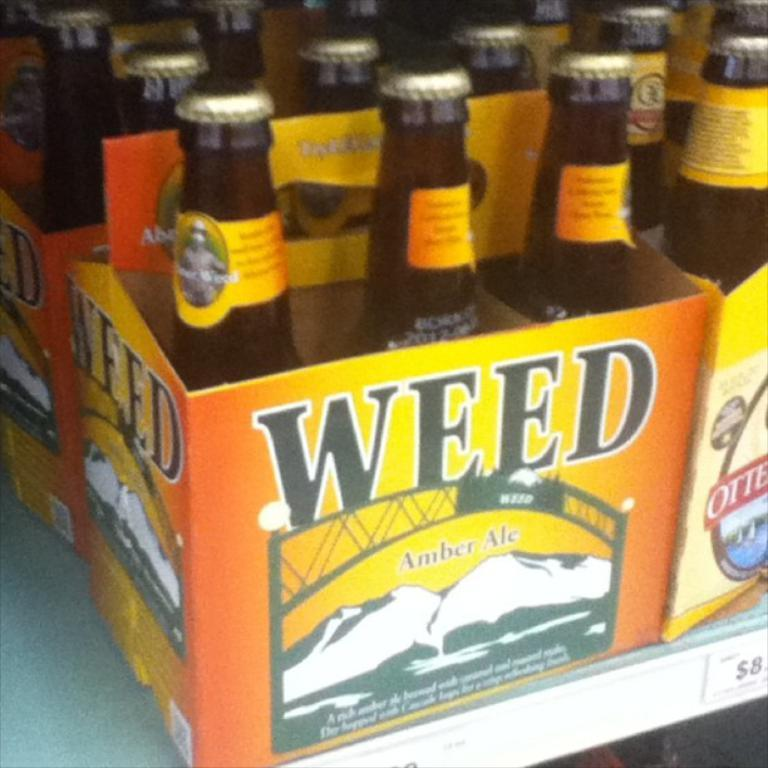<image>
Summarize the visual content of the image. Bottles of beer that are labeled weed amber ale 